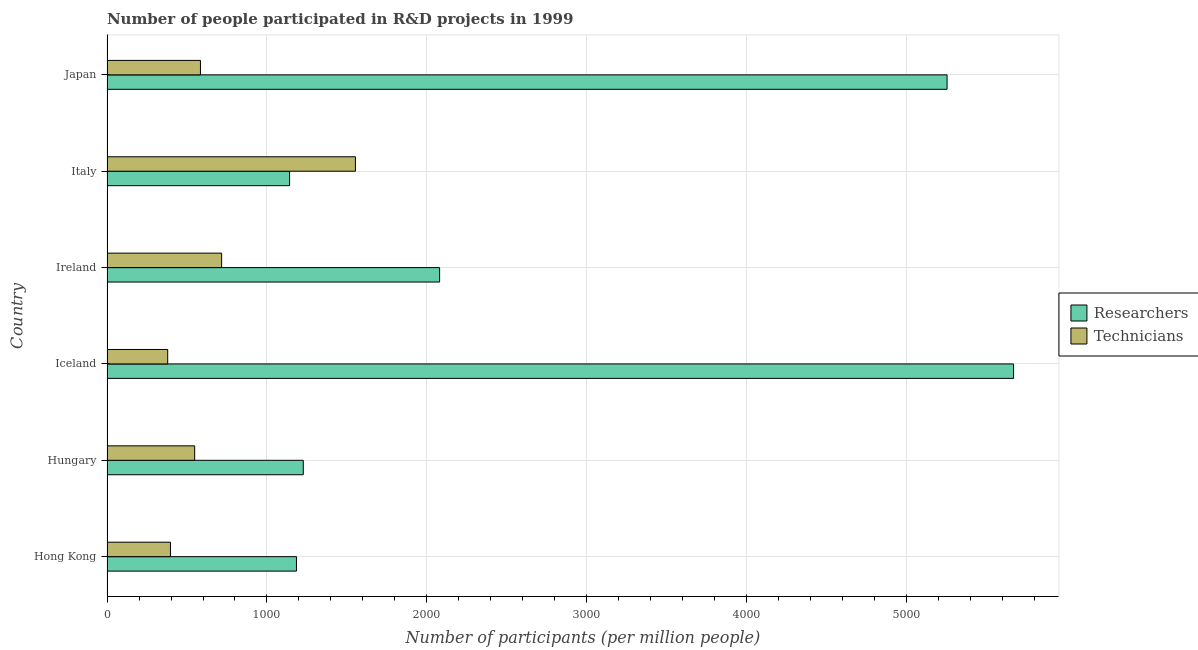How many different coloured bars are there?
Provide a short and direct response. 2. Are the number of bars on each tick of the Y-axis equal?
Keep it short and to the point. Yes. How many bars are there on the 3rd tick from the bottom?
Offer a very short reply. 2. What is the label of the 5th group of bars from the top?
Make the answer very short. Hungary. What is the number of researchers in Hong Kong?
Your response must be concise. 1184.31. Across all countries, what is the maximum number of researchers?
Offer a very short reply. 5666.8. Across all countries, what is the minimum number of researchers?
Keep it short and to the point. 1141.36. What is the total number of technicians in the graph?
Give a very brief answer. 4177.4. What is the difference between the number of researchers in Hong Kong and that in Iceland?
Offer a very short reply. -4482.49. What is the difference between the number of researchers in Ireland and the number of technicians in Italy?
Make the answer very short. 526.11. What is the average number of technicians per country?
Your answer should be very brief. 696.23. What is the difference between the number of technicians and number of researchers in Hong Kong?
Provide a short and direct response. -787.56. What is the ratio of the number of researchers in Hong Kong to that in Ireland?
Offer a very short reply. 0.57. Is the number of researchers in Hungary less than that in Italy?
Provide a succinct answer. No. What is the difference between the highest and the second highest number of technicians?
Give a very brief answer. 836.46. What is the difference between the highest and the lowest number of researchers?
Give a very brief answer. 4525.43. Is the sum of the number of technicians in Hungary and Italy greater than the maximum number of researchers across all countries?
Offer a terse response. No. What does the 1st bar from the top in Iceland represents?
Keep it short and to the point. Technicians. What does the 1st bar from the bottom in Japan represents?
Give a very brief answer. Researchers. How many bars are there?
Give a very brief answer. 12. What is the difference between two consecutive major ticks on the X-axis?
Provide a short and direct response. 1000. Are the values on the major ticks of X-axis written in scientific E-notation?
Keep it short and to the point. No. Does the graph contain any zero values?
Give a very brief answer. No. Does the graph contain grids?
Your answer should be compact. Yes. Where does the legend appear in the graph?
Your answer should be compact. Center right. How many legend labels are there?
Your answer should be very brief. 2. What is the title of the graph?
Make the answer very short. Number of people participated in R&D projects in 1999. What is the label or title of the X-axis?
Offer a terse response. Number of participants (per million people). What is the label or title of the Y-axis?
Your response must be concise. Country. What is the Number of participants (per million people) in Researchers in Hong Kong?
Provide a succinct answer. 1184.31. What is the Number of participants (per million people) in Technicians in Hong Kong?
Make the answer very short. 396.75. What is the Number of participants (per million people) of Researchers in Hungary?
Your response must be concise. 1226.85. What is the Number of participants (per million people) in Technicians in Hungary?
Provide a short and direct response. 547.89. What is the Number of participants (per million people) in Researchers in Iceland?
Your answer should be very brief. 5666.8. What is the Number of participants (per million people) of Technicians in Iceland?
Make the answer very short. 379.31. What is the Number of participants (per million people) in Researchers in Ireland?
Make the answer very short. 2079.01. What is the Number of participants (per million people) of Technicians in Ireland?
Offer a terse response. 716.45. What is the Number of participants (per million people) of Researchers in Italy?
Ensure brevity in your answer.  1141.36. What is the Number of participants (per million people) of Technicians in Italy?
Offer a terse response. 1552.91. What is the Number of participants (per million people) of Researchers in Japan?
Make the answer very short. 5251.07. What is the Number of participants (per million people) in Technicians in Japan?
Provide a short and direct response. 584.09. Across all countries, what is the maximum Number of participants (per million people) in Researchers?
Your answer should be compact. 5666.8. Across all countries, what is the maximum Number of participants (per million people) in Technicians?
Provide a short and direct response. 1552.91. Across all countries, what is the minimum Number of participants (per million people) of Researchers?
Offer a terse response. 1141.36. Across all countries, what is the minimum Number of participants (per million people) in Technicians?
Provide a short and direct response. 379.31. What is the total Number of participants (per million people) in Researchers in the graph?
Give a very brief answer. 1.65e+04. What is the total Number of participants (per million people) of Technicians in the graph?
Your response must be concise. 4177.4. What is the difference between the Number of participants (per million people) of Researchers in Hong Kong and that in Hungary?
Your answer should be compact. -42.54. What is the difference between the Number of participants (per million people) in Technicians in Hong Kong and that in Hungary?
Keep it short and to the point. -151.14. What is the difference between the Number of participants (per million people) in Researchers in Hong Kong and that in Iceland?
Your answer should be very brief. -4482.49. What is the difference between the Number of participants (per million people) of Technicians in Hong Kong and that in Iceland?
Offer a terse response. 17.44. What is the difference between the Number of participants (per million people) in Researchers in Hong Kong and that in Ireland?
Ensure brevity in your answer.  -894.71. What is the difference between the Number of participants (per million people) in Technicians in Hong Kong and that in Ireland?
Your answer should be compact. -319.7. What is the difference between the Number of participants (per million people) of Researchers in Hong Kong and that in Italy?
Offer a terse response. 42.94. What is the difference between the Number of participants (per million people) in Technicians in Hong Kong and that in Italy?
Make the answer very short. -1156.16. What is the difference between the Number of participants (per million people) in Researchers in Hong Kong and that in Japan?
Provide a short and direct response. -4066.76. What is the difference between the Number of participants (per million people) of Technicians in Hong Kong and that in Japan?
Ensure brevity in your answer.  -187.34. What is the difference between the Number of participants (per million people) in Researchers in Hungary and that in Iceland?
Offer a terse response. -4439.95. What is the difference between the Number of participants (per million people) of Technicians in Hungary and that in Iceland?
Keep it short and to the point. 168.58. What is the difference between the Number of participants (per million people) of Researchers in Hungary and that in Ireland?
Your answer should be very brief. -852.17. What is the difference between the Number of participants (per million people) in Technicians in Hungary and that in Ireland?
Offer a very short reply. -168.57. What is the difference between the Number of participants (per million people) in Researchers in Hungary and that in Italy?
Provide a short and direct response. 85.48. What is the difference between the Number of participants (per million people) of Technicians in Hungary and that in Italy?
Offer a very short reply. -1005.02. What is the difference between the Number of participants (per million people) of Researchers in Hungary and that in Japan?
Your answer should be compact. -4024.22. What is the difference between the Number of participants (per million people) of Technicians in Hungary and that in Japan?
Offer a terse response. -36.2. What is the difference between the Number of participants (per million people) in Researchers in Iceland and that in Ireland?
Your answer should be compact. 3587.78. What is the difference between the Number of participants (per million people) in Technicians in Iceland and that in Ireland?
Your answer should be compact. -337.15. What is the difference between the Number of participants (per million people) of Researchers in Iceland and that in Italy?
Ensure brevity in your answer.  4525.43. What is the difference between the Number of participants (per million people) of Technicians in Iceland and that in Italy?
Your answer should be very brief. -1173.6. What is the difference between the Number of participants (per million people) in Researchers in Iceland and that in Japan?
Give a very brief answer. 415.72. What is the difference between the Number of participants (per million people) in Technicians in Iceland and that in Japan?
Your answer should be compact. -204.78. What is the difference between the Number of participants (per million people) of Researchers in Ireland and that in Italy?
Provide a succinct answer. 937.65. What is the difference between the Number of participants (per million people) in Technicians in Ireland and that in Italy?
Your answer should be very brief. -836.45. What is the difference between the Number of participants (per million people) in Researchers in Ireland and that in Japan?
Offer a terse response. -3172.06. What is the difference between the Number of participants (per million people) in Technicians in Ireland and that in Japan?
Give a very brief answer. 132.36. What is the difference between the Number of participants (per million people) in Researchers in Italy and that in Japan?
Ensure brevity in your answer.  -4109.71. What is the difference between the Number of participants (per million people) of Technicians in Italy and that in Japan?
Your answer should be compact. 968.82. What is the difference between the Number of participants (per million people) in Researchers in Hong Kong and the Number of participants (per million people) in Technicians in Hungary?
Your answer should be very brief. 636.42. What is the difference between the Number of participants (per million people) of Researchers in Hong Kong and the Number of participants (per million people) of Technicians in Iceland?
Offer a terse response. 805. What is the difference between the Number of participants (per million people) of Researchers in Hong Kong and the Number of participants (per million people) of Technicians in Ireland?
Offer a very short reply. 467.86. What is the difference between the Number of participants (per million people) of Researchers in Hong Kong and the Number of participants (per million people) of Technicians in Italy?
Offer a terse response. -368.6. What is the difference between the Number of participants (per million people) of Researchers in Hong Kong and the Number of participants (per million people) of Technicians in Japan?
Your answer should be compact. 600.22. What is the difference between the Number of participants (per million people) in Researchers in Hungary and the Number of participants (per million people) in Technicians in Iceland?
Offer a very short reply. 847.54. What is the difference between the Number of participants (per million people) in Researchers in Hungary and the Number of participants (per million people) in Technicians in Ireland?
Your answer should be compact. 510.39. What is the difference between the Number of participants (per million people) of Researchers in Hungary and the Number of participants (per million people) of Technicians in Italy?
Provide a succinct answer. -326.06. What is the difference between the Number of participants (per million people) in Researchers in Hungary and the Number of participants (per million people) in Technicians in Japan?
Provide a succinct answer. 642.75. What is the difference between the Number of participants (per million people) of Researchers in Iceland and the Number of participants (per million people) of Technicians in Ireland?
Make the answer very short. 4950.34. What is the difference between the Number of participants (per million people) of Researchers in Iceland and the Number of participants (per million people) of Technicians in Italy?
Your answer should be very brief. 4113.89. What is the difference between the Number of participants (per million people) of Researchers in Iceland and the Number of participants (per million people) of Technicians in Japan?
Your answer should be very brief. 5082.7. What is the difference between the Number of participants (per million people) in Researchers in Ireland and the Number of participants (per million people) in Technicians in Italy?
Keep it short and to the point. 526.11. What is the difference between the Number of participants (per million people) in Researchers in Ireland and the Number of participants (per million people) in Technicians in Japan?
Make the answer very short. 1494.92. What is the difference between the Number of participants (per million people) of Researchers in Italy and the Number of participants (per million people) of Technicians in Japan?
Offer a terse response. 557.27. What is the average Number of participants (per million people) of Researchers per country?
Offer a very short reply. 2758.23. What is the average Number of participants (per million people) in Technicians per country?
Make the answer very short. 696.23. What is the difference between the Number of participants (per million people) of Researchers and Number of participants (per million people) of Technicians in Hong Kong?
Offer a terse response. 787.56. What is the difference between the Number of participants (per million people) of Researchers and Number of participants (per million people) of Technicians in Hungary?
Provide a short and direct response. 678.96. What is the difference between the Number of participants (per million people) in Researchers and Number of participants (per million people) in Technicians in Iceland?
Your answer should be compact. 5287.49. What is the difference between the Number of participants (per million people) in Researchers and Number of participants (per million people) in Technicians in Ireland?
Ensure brevity in your answer.  1362.56. What is the difference between the Number of participants (per million people) of Researchers and Number of participants (per million people) of Technicians in Italy?
Offer a terse response. -411.54. What is the difference between the Number of participants (per million people) in Researchers and Number of participants (per million people) in Technicians in Japan?
Your answer should be compact. 4666.98. What is the ratio of the Number of participants (per million people) of Researchers in Hong Kong to that in Hungary?
Make the answer very short. 0.97. What is the ratio of the Number of participants (per million people) of Technicians in Hong Kong to that in Hungary?
Provide a short and direct response. 0.72. What is the ratio of the Number of participants (per million people) of Researchers in Hong Kong to that in Iceland?
Your response must be concise. 0.21. What is the ratio of the Number of participants (per million people) of Technicians in Hong Kong to that in Iceland?
Your answer should be compact. 1.05. What is the ratio of the Number of participants (per million people) in Researchers in Hong Kong to that in Ireland?
Offer a terse response. 0.57. What is the ratio of the Number of participants (per million people) of Technicians in Hong Kong to that in Ireland?
Provide a succinct answer. 0.55. What is the ratio of the Number of participants (per million people) in Researchers in Hong Kong to that in Italy?
Give a very brief answer. 1.04. What is the ratio of the Number of participants (per million people) of Technicians in Hong Kong to that in Italy?
Keep it short and to the point. 0.26. What is the ratio of the Number of participants (per million people) of Researchers in Hong Kong to that in Japan?
Ensure brevity in your answer.  0.23. What is the ratio of the Number of participants (per million people) of Technicians in Hong Kong to that in Japan?
Provide a short and direct response. 0.68. What is the ratio of the Number of participants (per million people) of Researchers in Hungary to that in Iceland?
Make the answer very short. 0.22. What is the ratio of the Number of participants (per million people) in Technicians in Hungary to that in Iceland?
Make the answer very short. 1.44. What is the ratio of the Number of participants (per million people) in Researchers in Hungary to that in Ireland?
Make the answer very short. 0.59. What is the ratio of the Number of participants (per million people) in Technicians in Hungary to that in Ireland?
Provide a short and direct response. 0.76. What is the ratio of the Number of participants (per million people) of Researchers in Hungary to that in Italy?
Offer a very short reply. 1.07. What is the ratio of the Number of participants (per million people) in Technicians in Hungary to that in Italy?
Give a very brief answer. 0.35. What is the ratio of the Number of participants (per million people) in Researchers in Hungary to that in Japan?
Your answer should be very brief. 0.23. What is the ratio of the Number of participants (per million people) of Technicians in Hungary to that in Japan?
Give a very brief answer. 0.94. What is the ratio of the Number of participants (per million people) of Researchers in Iceland to that in Ireland?
Ensure brevity in your answer.  2.73. What is the ratio of the Number of participants (per million people) in Technicians in Iceland to that in Ireland?
Make the answer very short. 0.53. What is the ratio of the Number of participants (per million people) in Researchers in Iceland to that in Italy?
Keep it short and to the point. 4.96. What is the ratio of the Number of participants (per million people) in Technicians in Iceland to that in Italy?
Your answer should be compact. 0.24. What is the ratio of the Number of participants (per million people) in Researchers in Iceland to that in Japan?
Your response must be concise. 1.08. What is the ratio of the Number of participants (per million people) in Technicians in Iceland to that in Japan?
Keep it short and to the point. 0.65. What is the ratio of the Number of participants (per million people) in Researchers in Ireland to that in Italy?
Ensure brevity in your answer.  1.82. What is the ratio of the Number of participants (per million people) in Technicians in Ireland to that in Italy?
Provide a succinct answer. 0.46. What is the ratio of the Number of participants (per million people) in Researchers in Ireland to that in Japan?
Your answer should be compact. 0.4. What is the ratio of the Number of participants (per million people) of Technicians in Ireland to that in Japan?
Keep it short and to the point. 1.23. What is the ratio of the Number of participants (per million people) of Researchers in Italy to that in Japan?
Keep it short and to the point. 0.22. What is the ratio of the Number of participants (per million people) of Technicians in Italy to that in Japan?
Offer a very short reply. 2.66. What is the difference between the highest and the second highest Number of participants (per million people) in Researchers?
Your answer should be compact. 415.72. What is the difference between the highest and the second highest Number of participants (per million people) in Technicians?
Give a very brief answer. 836.45. What is the difference between the highest and the lowest Number of participants (per million people) of Researchers?
Offer a very short reply. 4525.43. What is the difference between the highest and the lowest Number of participants (per million people) of Technicians?
Keep it short and to the point. 1173.6. 